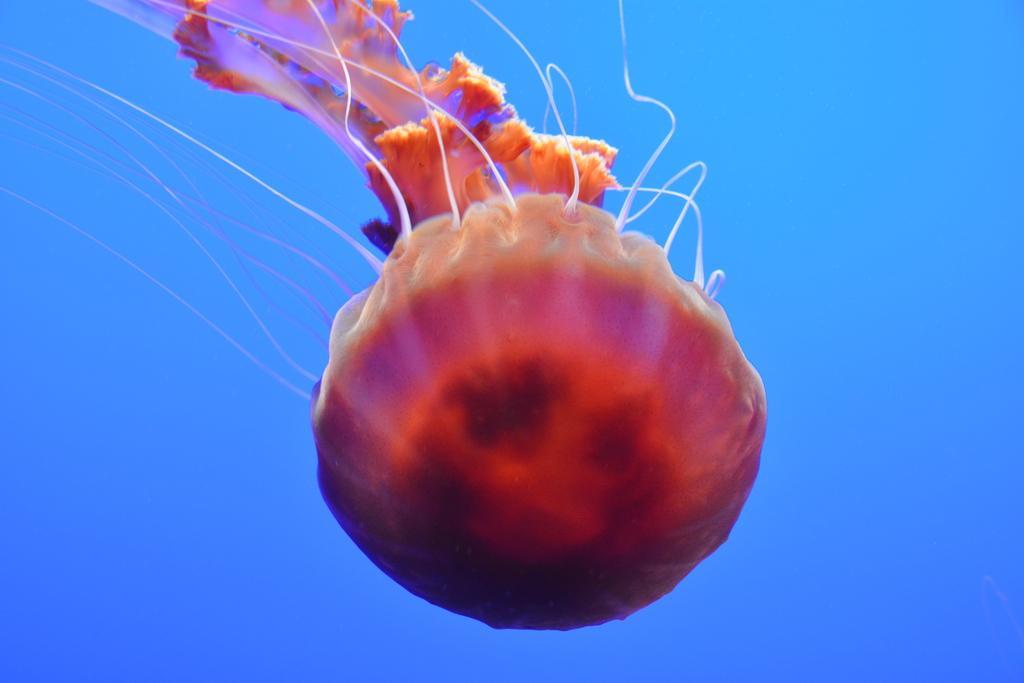Can you describe this image briefly? Here we can see jellyfish. Background it is blue color. 